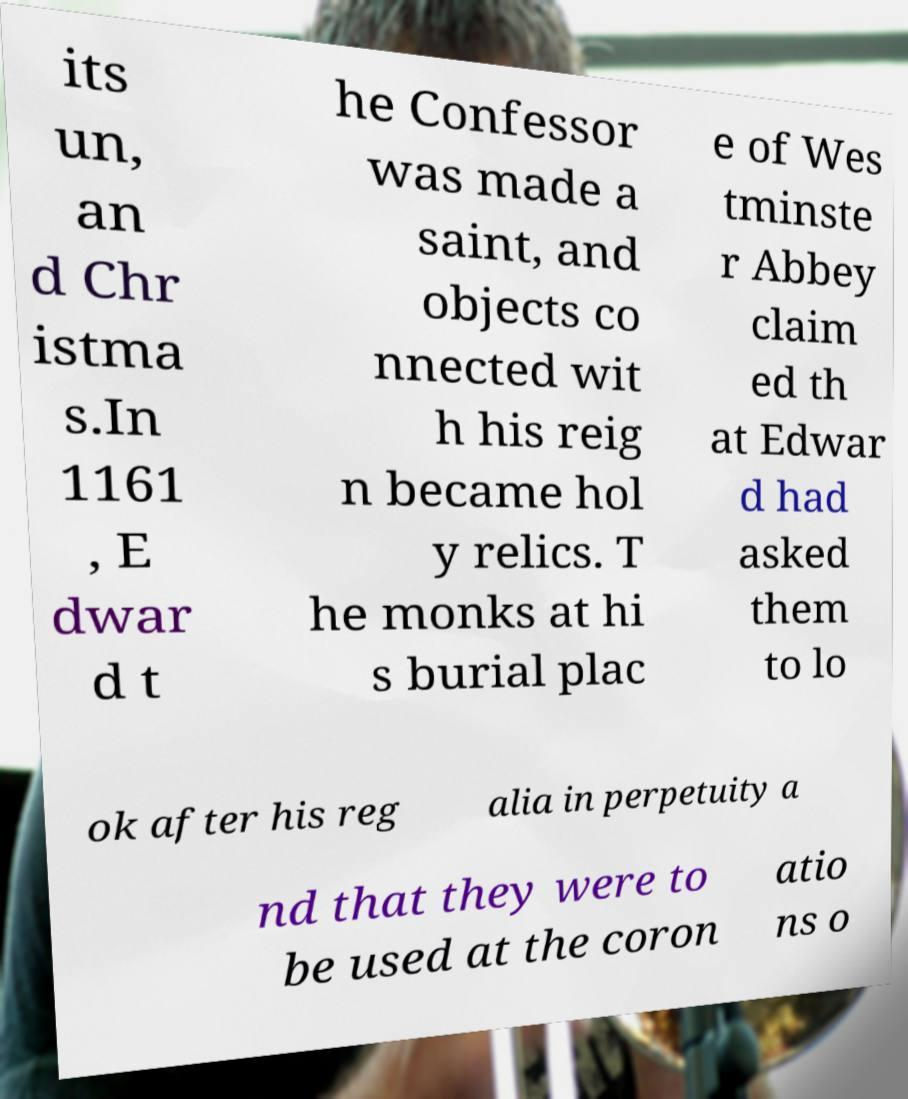I need the written content from this picture converted into text. Can you do that? its un, an d Chr istma s.In 1161 , E dwar d t he Confessor was made a saint, and objects co nnected wit h his reig n became hol y relics. T he monks at hi s burial plac e of Wes tminste r Abbey claim ed th at Edwar d had asked them to lo ok after his reg alia in perpetuity a nd that they were to be used at the coron atio ns o 